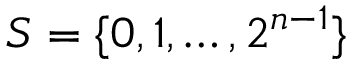<formula> <loc_0><loc_0><loc_500><loc_500>S = \{ 0 , 1 , \dots , 2 ^ { n - 1 } \}</formula> 